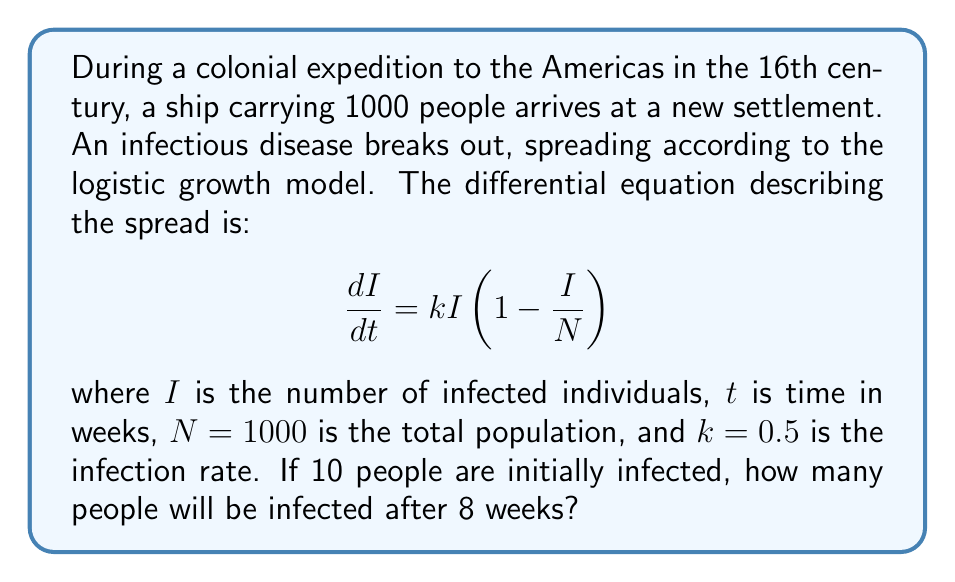Teach me how to tackle this problem. To solve this problem, we need to integrate the logistic differential equation:

1) The logistic equation is:
   $$\frac{dI}{dt} = kI(1-\frac{I}{N})$$

2) Separating variables:
   $$\frac{dI}{I(1-\frac{I}{N})} = kdt$$

3) Integrating both sides:
   $$\int \frac{dI}{I(1-\frac{I}{N})} = \int kdt$$

4) The left side integrates to:
   $$-\ln|1-\frac{I}{N}| - \ln|I| = kt + C$$

5) Simplifying and solving for $I$:
   $$I(t) = \frac{N}{1 + Ce^{-kt}}$$

6) Using the initial condition $I(0) = 10$:
   $$10 = \frac{1000}{1 + C}$$
   $$C = 99$$

7) Therefore, our solution is:
   $$I(t) = \frac{1000}{1 + 99e^{-0.5t}}$$

8) Evaluating at $t = 8$:
   $$I(8) = \frac{1000}{1 + 99e^{-0.5(8)}} \approx 941.19$$

9) Rounding to the nearest whole number:
   $$I(8) \approx 941$$
Answer: 941 people 